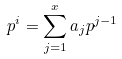Convert formula to latex. <formula><loc_0><loc_0><loc_500><loc_500>p ^ { i } = \sum _ { j = 1 } ^ { x } a _ { j } p ^ { j - 1 }</formula> 